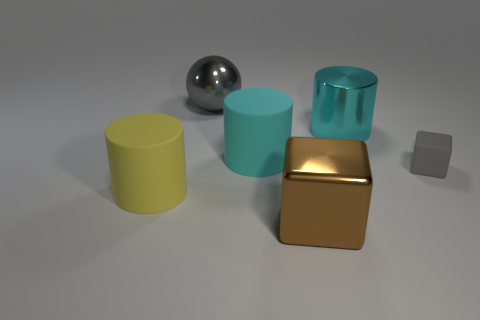Can you describe the textures of the objects? Certainly. The brown cube appears to have a matte surface, the grey cube seems to have a slightly rougher texture, the yellow and cyan cylinders have smoother surfaces, and the spherical object has a high-gloss finish. 